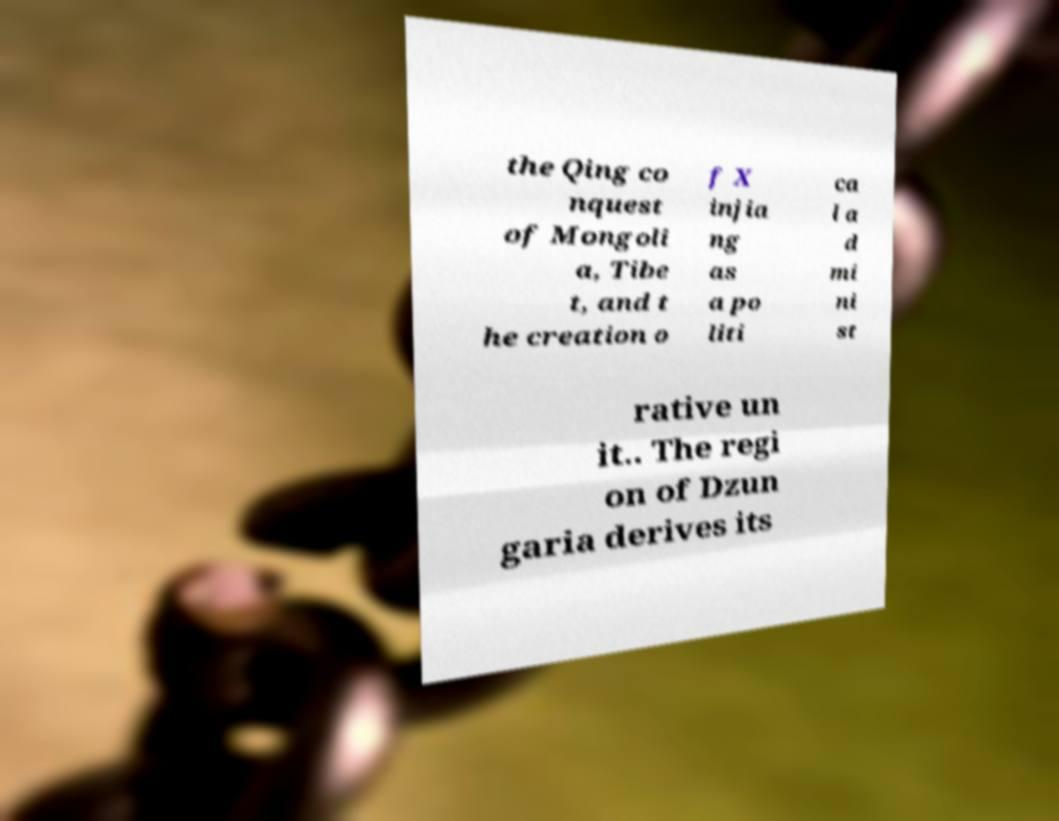Could you assist in decoding the text presented in this image and type it out clearly? the Qing co nquest of Mongoli a, Tibe t, and t he creation o f X injia ng as a po liti ca l a d mi ni st rative un it.. The regi on of Dzun garia derives its 